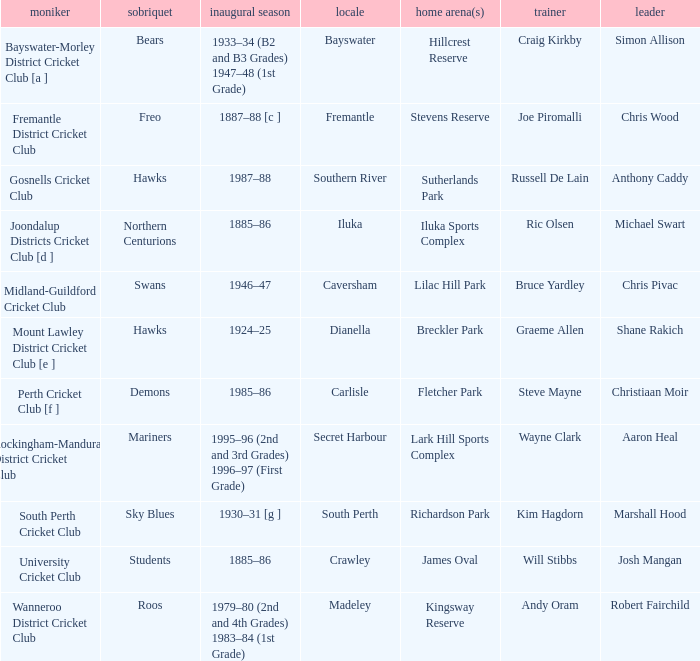For location Caversham, what is the name of the captain? Chris Pivac. 